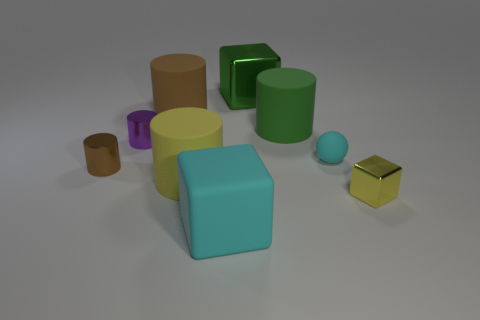There is a object to the left of the tiny purple cylinder; is its shape the same as the tiny metal object behind the cyan ball?
Your answer should be compact. Yes. Is the number of green things that are in front of the large cyan object the same as the number of tiny objects that are behind the green rubber cylinder?
Provide a short and direct response. Yes. What is the shape of the big object that is in front of the block right of the large rubber thing on the right side of the cyan block?
Provide a succinct answer. Cube. Are the large cube behind the small purple metallic cylinder and the small brown thing that is behind the yellow cube made of the same material?
Provide a succinct answer. Yes. What shape is the small brown metal thing that is to the left of the large cyan rubber cube?
Offer a very short reply. Cylinder. Are there fewer small rubber spheres than large shiny cylinders?
Give a very brief answer. No. Is there a big cylinder that is behind the cyan matte object that is on the right side of the large block behind the tiny cyan rubber ball?
Your answer should be compact. Yes. How many matte things are either blue cubes or tiny cyan balls?
Make the answer very short. 1. Is the color of the tiny ball the same as the tiny metal block?
Your answer should be compact. No. There is a small ball; what number of objects are to the right of it?
Your answer should be very brief. 1. 